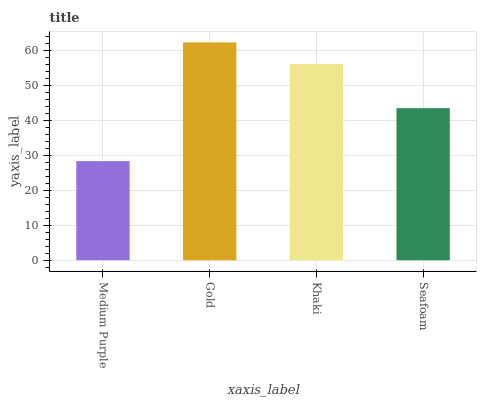Is Medium Purple the minimum?
Answer yes or no. Yes. Is Gold the maximum?
Answer yes or no. Yes. Is Khaki the minimum?
Answer yes or no. No. Is Khaki the maximum?
Answer yes or no. No. Is Gold greater than Khaki?
Answer yes or no. Yes. Is Khaki less than Gold?
Answer yes or no. Yes. Is Khaki greater than Gold?
Answer yes or no. No. Is Gold less than Khaki?
Answer yes or no. No. Is Khaki the high median?
Answer yes or no. Yes. Is Seafoam the low median?
Answer yes or no. Yes. Is Seafoam the high median?
Answer yes or no. No. Is Medium Purple the low median?
Answer yes or no. No. 